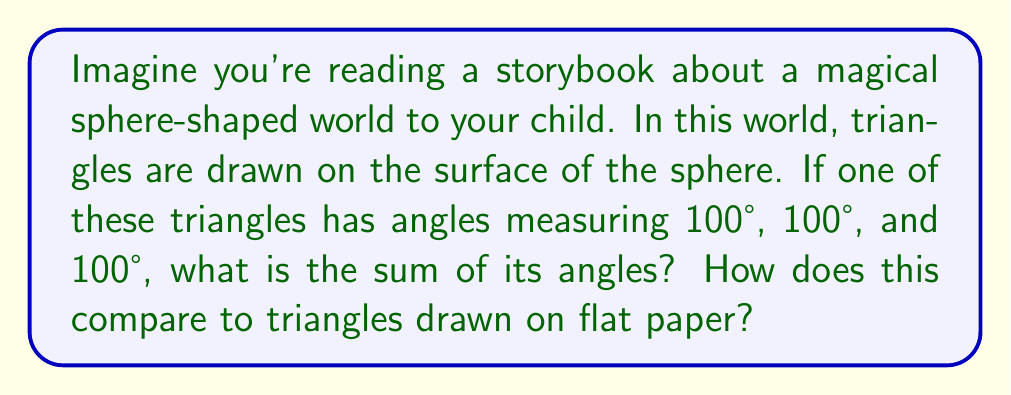Could you help me with this problem? Let's explore this step-by-step:

1) First, recall that on a flat surface (like paper), the sum of angles in a triangle is always 180°. This is what your child might be familiar with from school.

2) However, on a sphere (a curved surface), the rules are different. This is part of what we call "non-Euclidean geometry".

3) On a sphere, the sum of angles in a triangle is always greater than 180°. The extra amount depends on the size of the triangle relative to the sphere.

4) In this case, we're given a triangle with three equal angles, each measuring 100°.

5) To find the sum, we simply add these angles:

   $$ 100° + 100° + 100° = 300° $$

6) Compare this to a flat triangle:
   $$ 300° - 180° = 120° $$
   The spherical triangle's angles sum to 120° more than a flat triangle.

7) This extra 120° is called the "spherical excess". It tells us about the portion of the sphere's surface that the triangle covers.

8) You could explain to your child that this is why the magical sphere-world is different from our flat paper-world. Shapes behave differently on curved surfaces!
Answer: 300°; 120° more than a flat triangle 